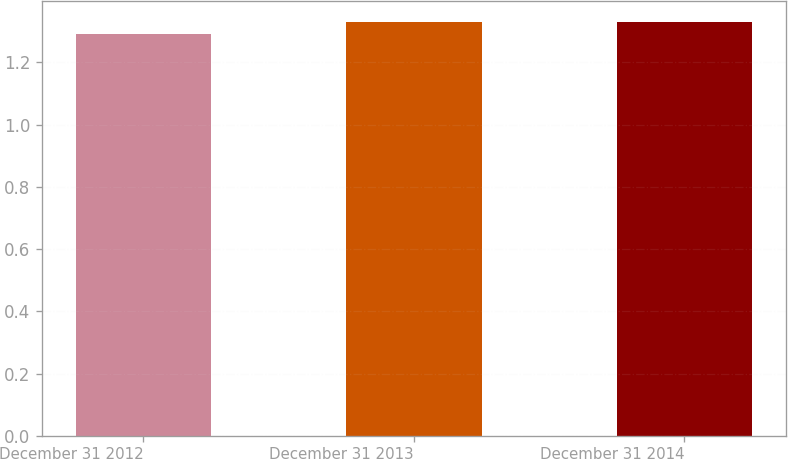<chart> <loc_0><loc_0><loc_500><loc_500><bar_chart><fcel>December 31 2012<fcel>December 31 2013<fcel>December 31 2014<nl><fcel>1.29<fcel>1.33<fcel>1.33<nl></chart> 